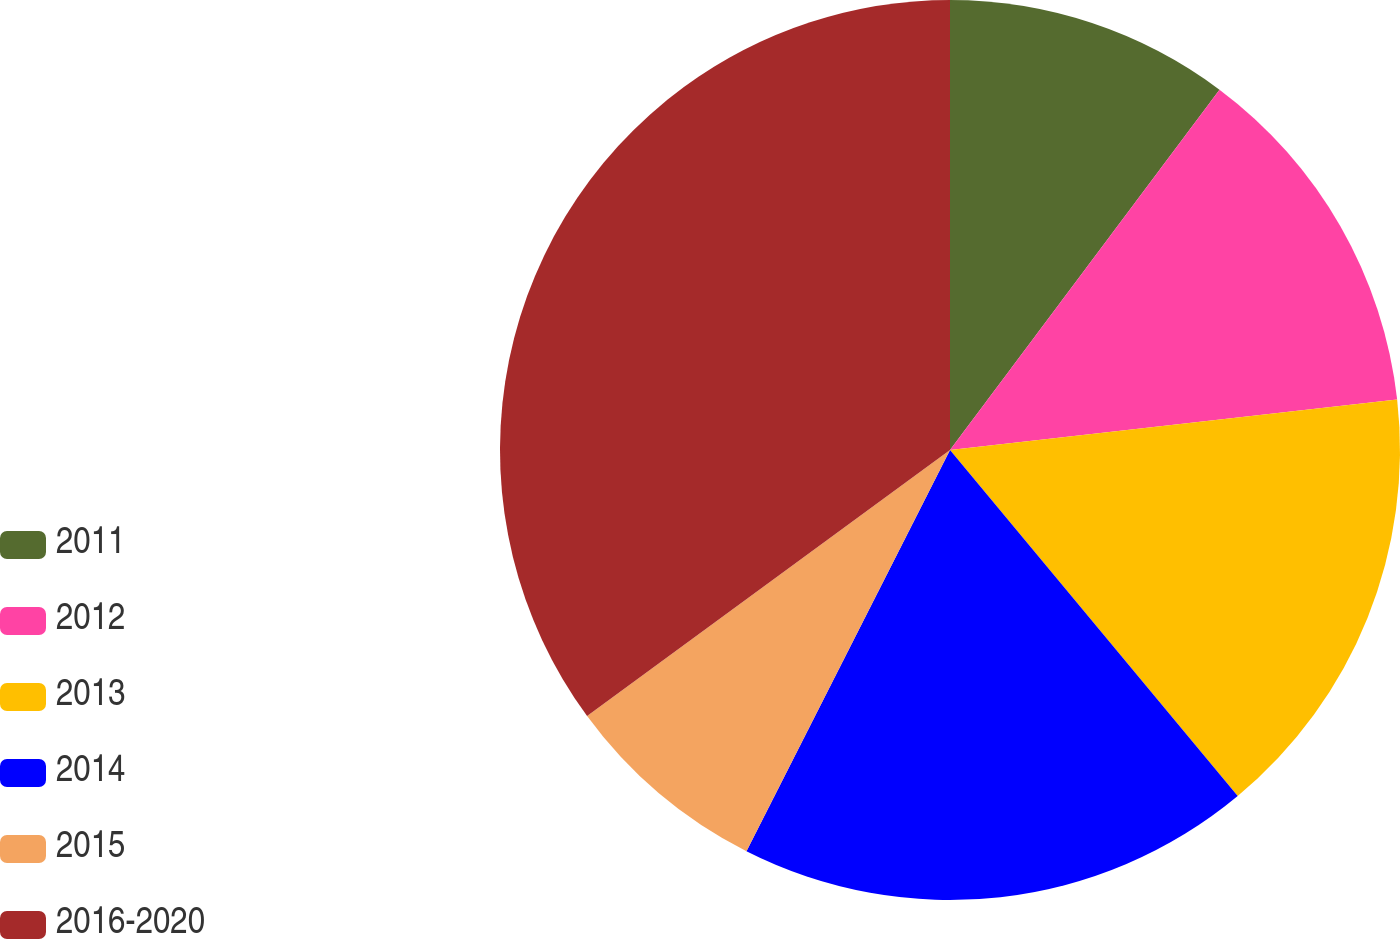Convert chart. <chart><loc_0><loc_0><loc_500><loc_500><pie_chart><fcel>2011<fcel>2012<fcel>2013<fcel>2014<fcel>2015<fcel>2016-2020<nl><fcel>10.22%<fcel>12.99%<fcel>15.75%<fcel>18.51%<fcel>7.46%<fcel>35.07%<nl></chart> 